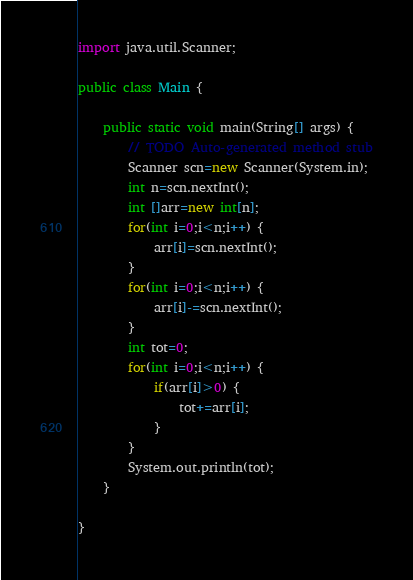Convert code to text. <code><loc_0><loc_0><loc_500><loc_500><_Java_>
import java.util.Scanner;

public class Main {

	public static void main(String[] args) {
		// TODO Auto-generated method stub
		Scanner scn=new Scanner(System.in);
		int n=scn.nextInt();
		int []arr=new int[n];
		for(int i=0;i<n;i++) {
			arr[i]=scn.nextInt();
		}
		for(int i=0;i<n;i++) {
			arr[i]-=scn.nextInt();
		}
		int tot=0;
		for(int i=0;i<n;i++) {
			if(arr[i]>0) {
				tot+=arr[i];
			}
		}
		System.out.println(tot);
	}

}
</code> 